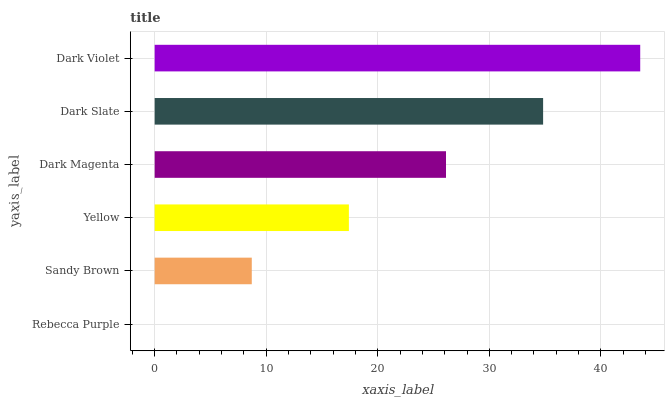Is Rebecca Purple the minimum?
Answer yes or no. Yes. Is Dark Violet the maximum?
Answer yes or no. Yes. Is Sandy Brown the minimum?
Answer yes or no. No. Is Sandy Brown the maximum?
Answer yes or no. No. Is Sandy Brown greater than Rebecca Purple?
Answer yes or no. Yes. Is Rebecca Purple less than Sandy Brown?
Answer yes or no. Yes. Is Rebecca Purple greater than Sandy Brown?
Answer yes or no. No. Is Sandy Brown less than Rebecca Purple?
Answer yes or no. No. Is Dark Magenta the high median?
Answer yes or no. Yes. Is Yellow the low median?
Answer yes or no. Yes. Is Yellow the high median?
Answer yes or no. No. Is Sandy Brown the low median?
Answer yes or no. No. 